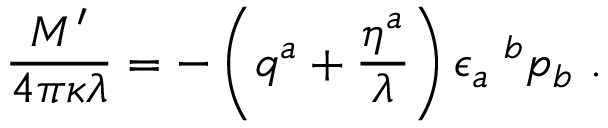<formula> <loc_0><loc_0><loc_500><loc_500>{ \frac { M ^ { \prime } } { 4 \pi \kappa \lambda } } = - \left ( q ^ { a } + { \frac { \eta ^ { a } } { \lambda } } \right ) \epsilon _ { a } ^ { b } p _ { b } .</formula> 